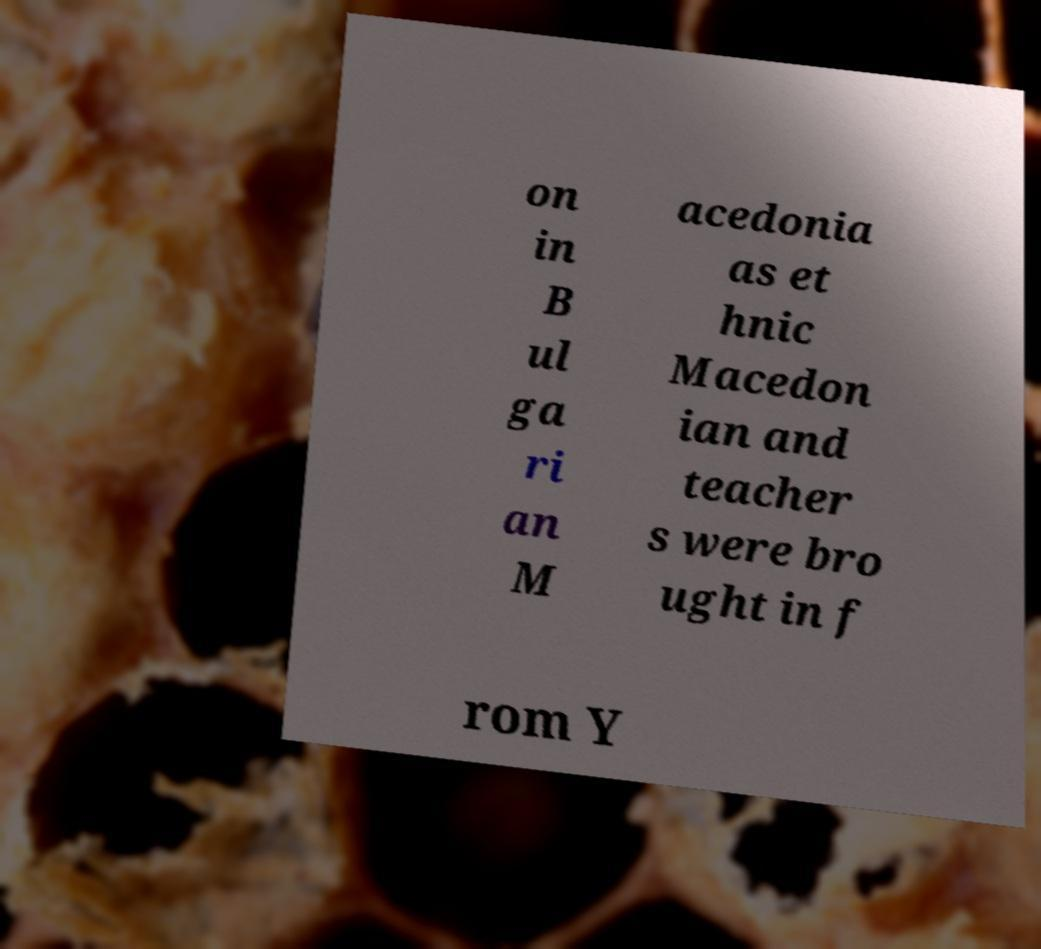Could you extract and type out the text from this image? on in B ul ga ri an M acedonia as et hnic Macedon ian and teacher s were bro ught in f rom Y 